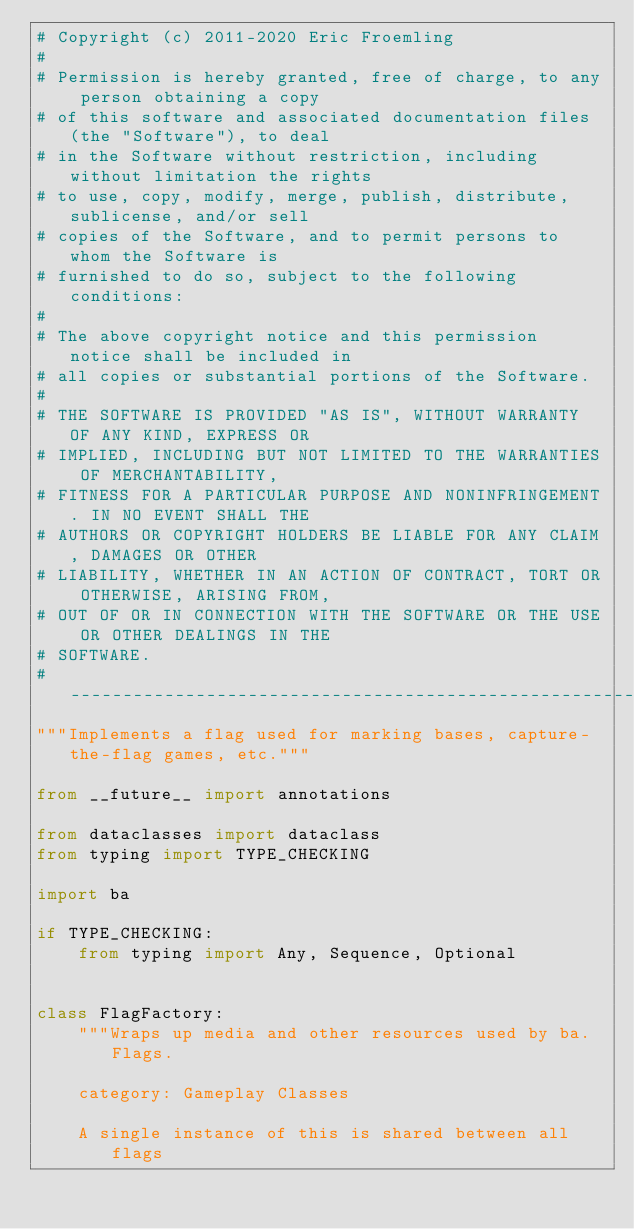Convert code to text. <code><loc_0><loc_0><loc_500><loc_500><_Python_># Copyright (c) 2011-2020 Eric Froemling
#
# Permission is hereby granted, free of charge, to any person obtaining a copy
# of this software and associated documentation files (the "Software"), to deal
# in the Software without restriction, including without limitation the rights
# to use, copy, modify, merge, publish, distribute, sublicense, and/or sell
# copies of the Software, and to permit persons to whom the Software is
# furnished to do so, subject to the following conditions:
#
# The above copyright notice and this permission notice shall be included in
# all copies or substantial portions of the Software.
#
# THE SOFTWARE IS PROVIDED "AS IS", WITHOUT WARRANTY OF ANY KIND, EXPRESS OR
# IMPLIED, INCLUDING BUT NOT LIMITED TO THE WARRANTIES OF MERCHANTABILITY,
# FITNESS FOR A PARTICULAR PURPOSE AND NONINFRINGEMENT. IN NO EVENT SHALL THE
# AUTHORS OR COPYRIGHT HOLDERS BE LIABLE FOR ANY CLAIM, DAMAGES OR OTHER
# LIABILITY, WHETHER IN AN ACTION OF CONTRACT, TORT OR OTHERWISE, ARISING FROM,
# OUT OF OR IN CONNECTION WITH THE SOFTWARE OR THE USE OR OTHER DEALINGS IN THE
# SOFTWARE.
# -----------------------------------------------------------------------------
"""Implements a flag used for marking bases, capture-the-flag games, etc."""

from __future__ import annotations

from dataclasses import dataclass
from typing import TYPE_CHECKING

import ba

if TYPE_CHECKING:
    from typing import Any, Sequence, Optional


class FlagFactory:
    """Wraps up media and other resources used by ba.Flags.

    category: Gameplay Classes

    A single instance of this is shared between all flags</code> 